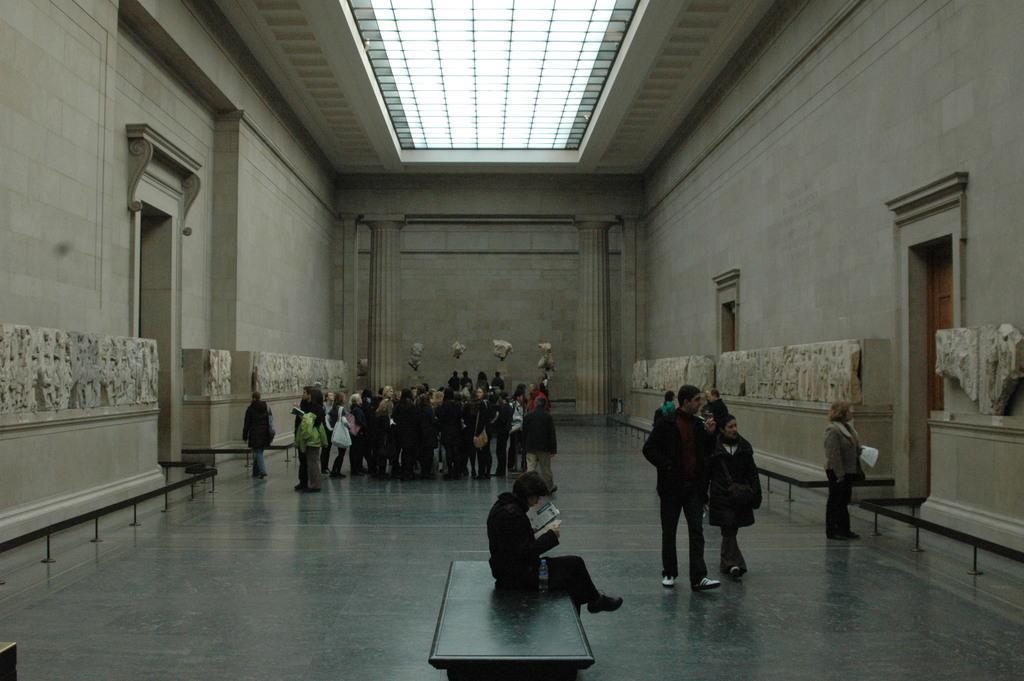Could you give a brief overview of what you see in this image? In this image I can see people where one is sitting and rest all are standing. I can see most of them are wearing jackets and few of them are carrying bags. Here I can see a brown colour door. 